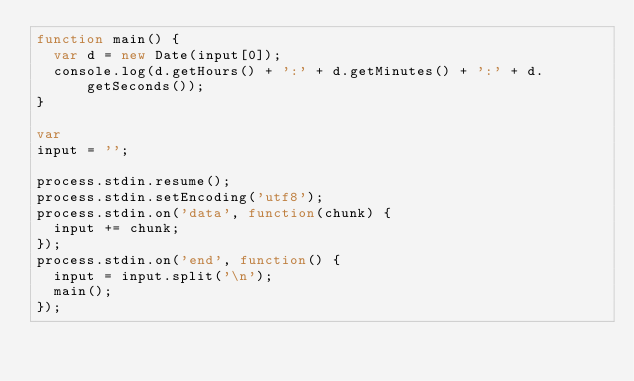<code> <loc_0><loc_0><loc_500><loc_500><_JavaScript_>function main() {
  var d = new Date(input[0]);
  console.log(d.getHours() + ':' + d.getMinutes() + ':' + d.getSeconds());
}

var
input = '';

process.stdin.resume();
process.stdin.setEncoding('utf8');
process.stdin.on('data', function(chunk) {
  input += chunk;
});
process.stdin.on('end', function() {
  input = input.split('\n');
  main();
});</code> 